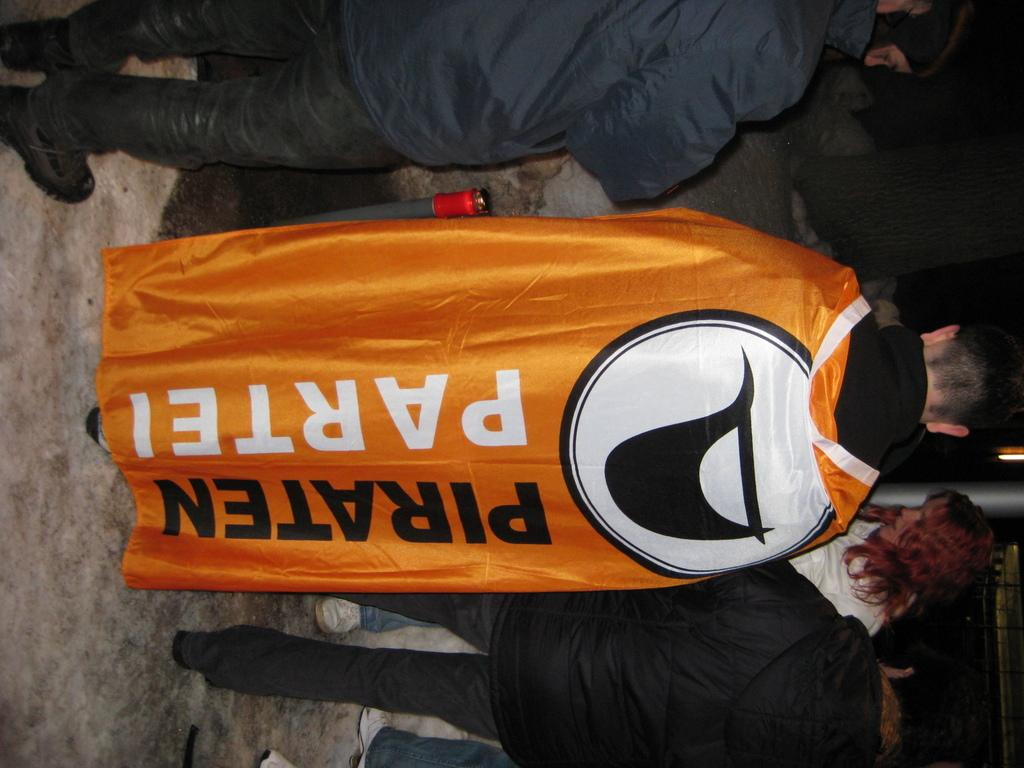<image>
Offer a succinct explanation of the picture presented. A man wears an orange Piraten Partei flag as a cape. 